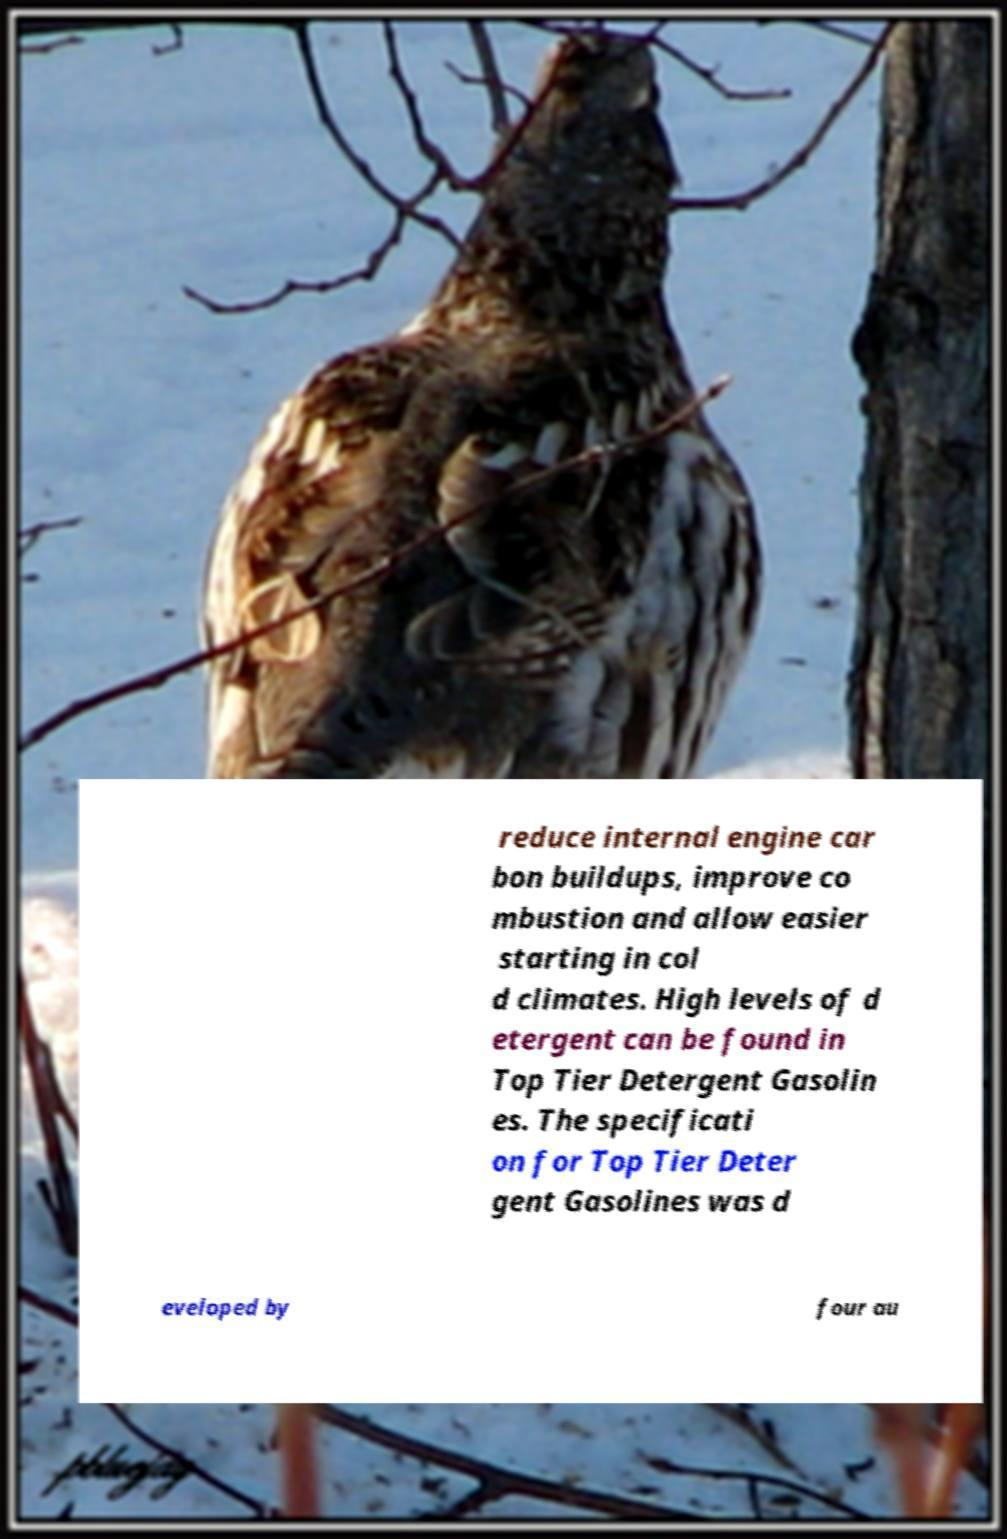For documentation purposes, I need the text within this image transcribed. Could you provide that? reduce internal engine car bon buildups, improve co mbustion and allow easier starting in col d climates. High levels of d etergent can be found in Top Tier Detergent Gasolin es. The specificati on for Top Tier Deter gent Gasolines was d eveloped by four au 